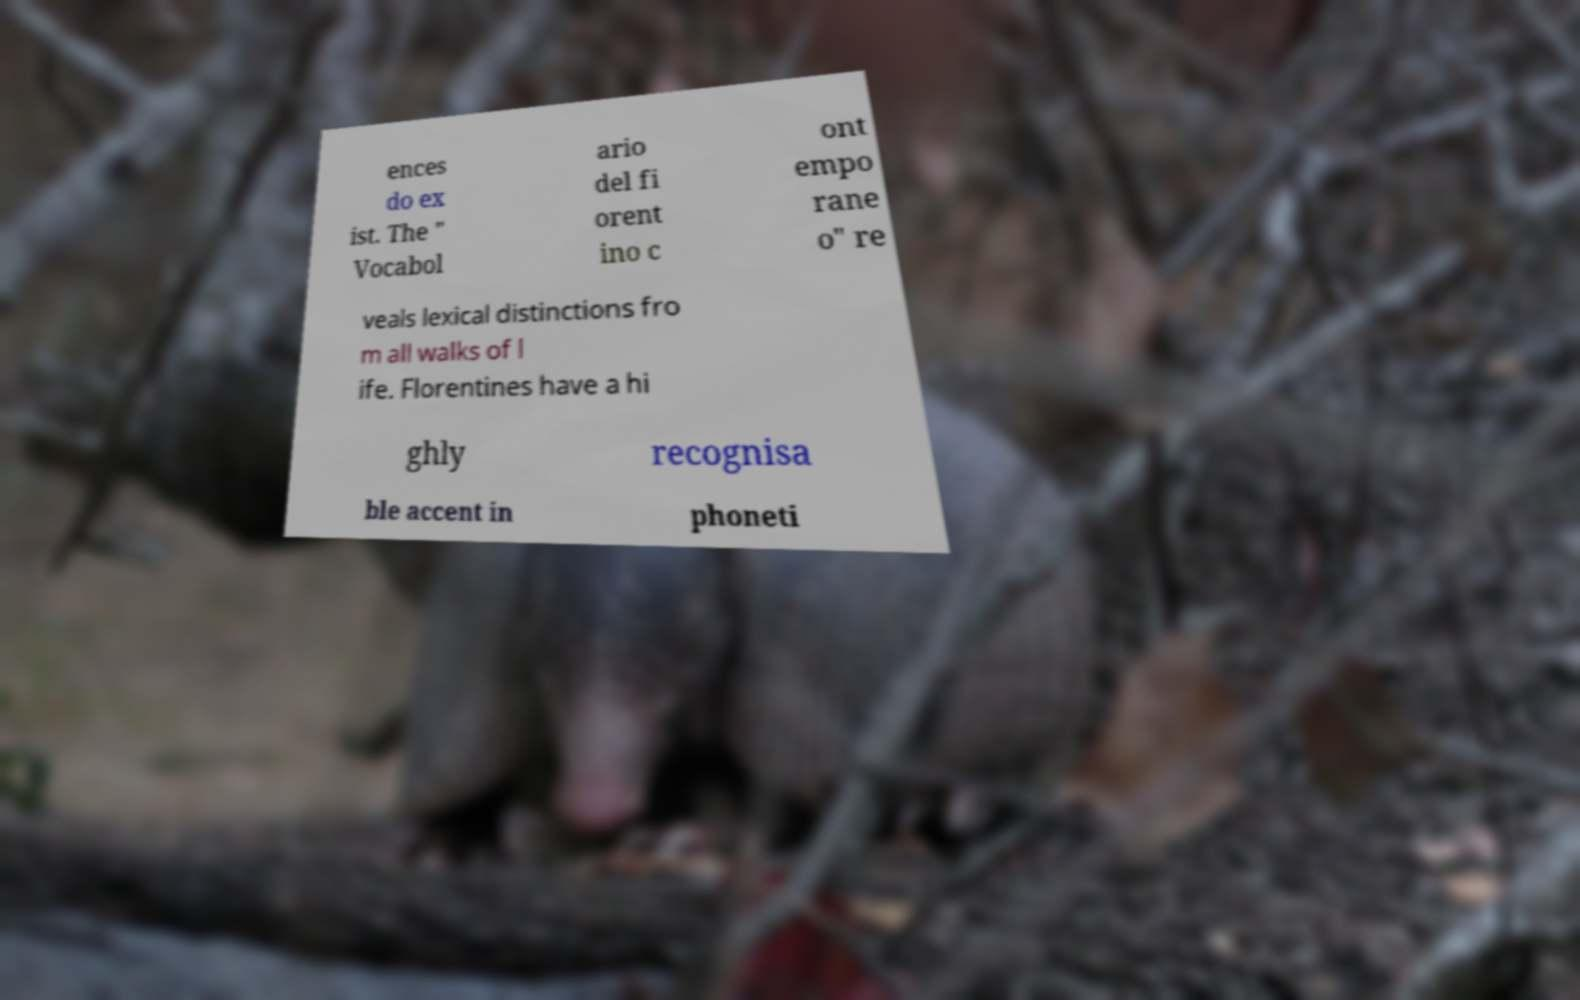Please identify and transcribe the text found in this image. ences do ex ist. The " Vocabol ario del fi orent ino c ont empo rane o" re veals lexical distinctions fro m all walks of l ife. Florentines have a hi ghly recognisa ble accent in phoneti 